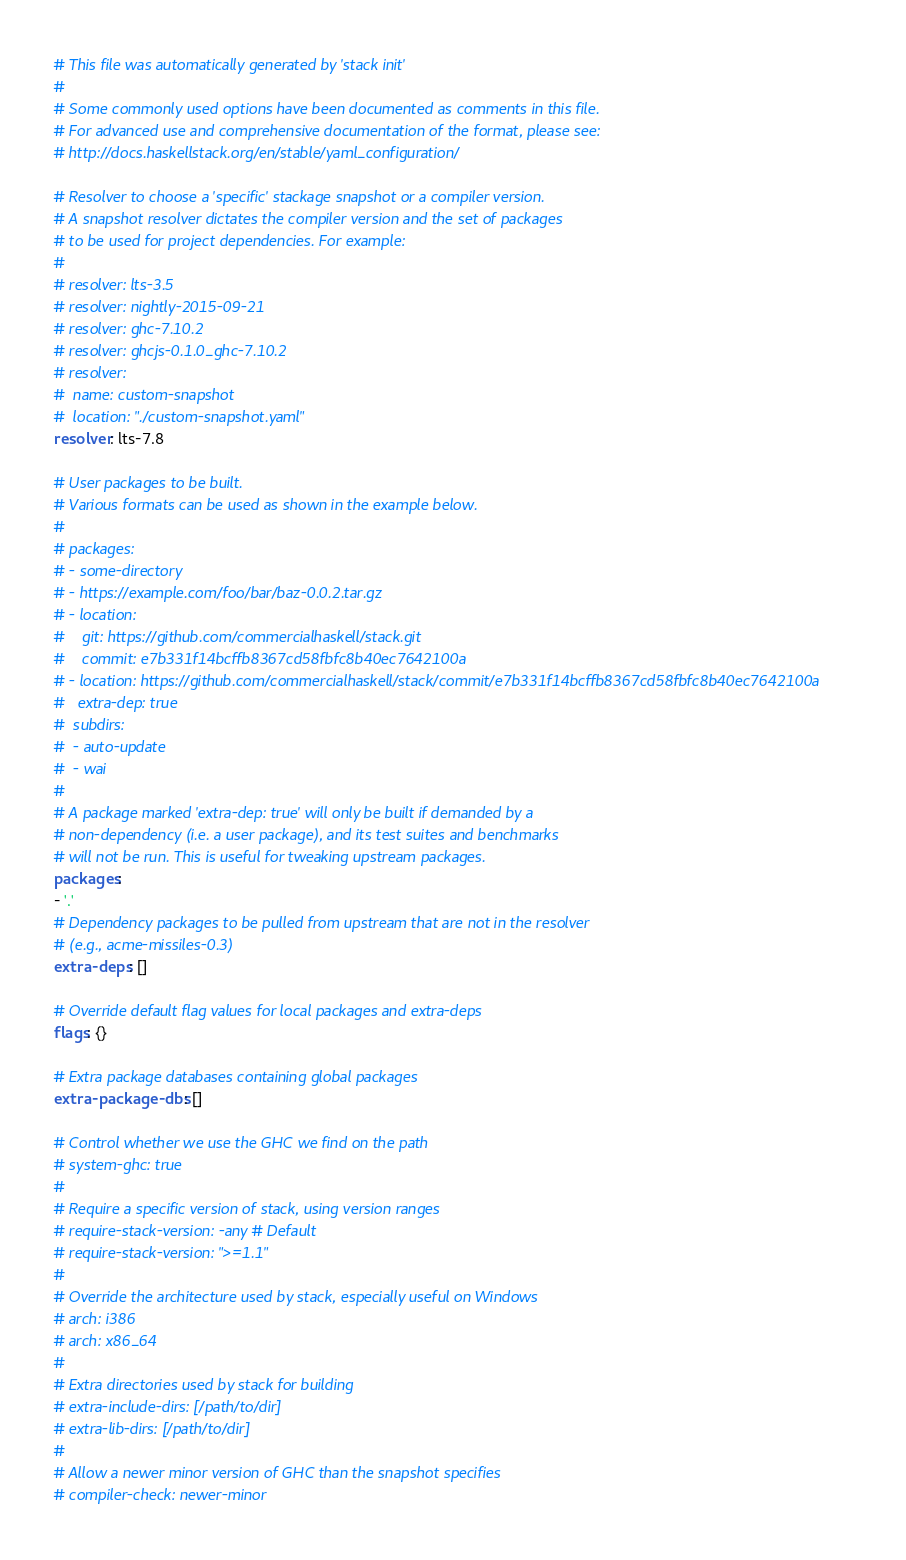Convert code to text. <code><loc_0><loc_0><loc_500><loc_500><_YAML_># This file was automatically generated by 'stack init'
# 
# Some commonly used options have been documented as comments in this file.
# For advanced use and comprehensive documentation of the format, please see:
# http://docs.haskellstack.org/en/stable/yaml_configuration/

# Resolver to choose a 'specific' stackage snapshot or a compiler version.
# A snapshot resolver dictates the compiler version and the set of packages
# to be used for project dependencies. For example:
# 
# resolver: lts-3.5
# resolver: nightly-2015-09-21
# resolver: ghc-7.10.2
# resolver: ghcjs-0.1.0_ghc-7.10.2
# resolver:
#  name: custom-snapshot
#  location: "./custom-snapshot.yaml"
resolver: lts-7.8

# User packages to be built.
# Various formats can be used as shown in the example below.
# 
# packages:
# - some-directory
# - https://example.com/foo/bar/baz-0.0.2.tar.gz
# - location:
#    git: https://github.com/commercialhaskell/stack.git
#    commit: e7b331f14bcffb8367cd58fbfc8b40ec7642100a
# - location: https://github.com/commercialhaskell/stack/commit/e7b331f14bcffb8367cd58fbfc8b40ec7642100a
#   extra-dep: true
#  subdirs:
#  - auto-update
#  - wai
# 
# A package marked 'extra-dep: true' will only be built if demanded by a
# non-dependency (i.e. a user package), and its test suites and benchmarks
# will not be run. This is useful for tweaking upstream packages.
packages:
- '.'
# Dependency packages to be pulled from upstream that are not in the resolver
# (e.g., acme-missiles-0.3)
extra-deps: []

# Override default flag values for local packages and extra-deps
flags: {}

# Extra package databases containing global packages
extra-package-dbs: []

# Control whether we use the GHC we find on the path
# system-ghc: true
# 
# Require a specific version of stack, using version ranges
# require-stack-version: -any # Default
# require-stack-version: ">=1.1"
# 
# Override the architecture used by stack, especially useful on Windows
# arch: i386
# arch: x86_64
# 
# Extra directories used by stack for building
# extra-include-dirs: [/path/to/dir]
# extra-lib-dirs: [/path/to/dir]
# 
# Allow a newer minor version of GHC than the snapshot specifies
# compiler-check: newer-minor</code> 